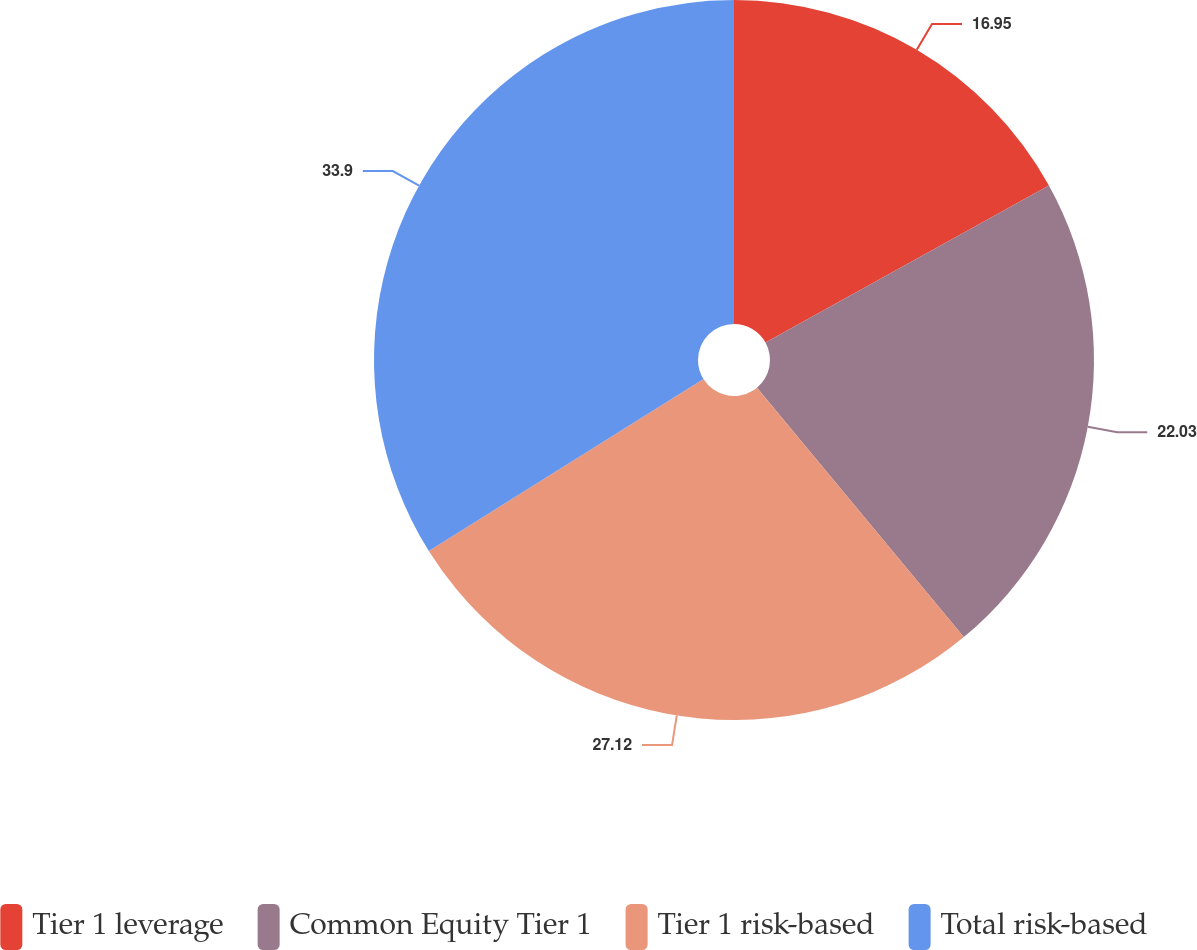Convert chart. <chart><loc_0><loc_0><loc_500><loc_500><pie_chart><fcel>Tier 1 leverage<fcel>Common Equity Tier 1<fcel>Tier 1 risk-based<fcel>Total risk-based<nl><fcel>16.95%<fcel>22.03%<fcel>27.12%<fcel>33.9%<nl></chart> 